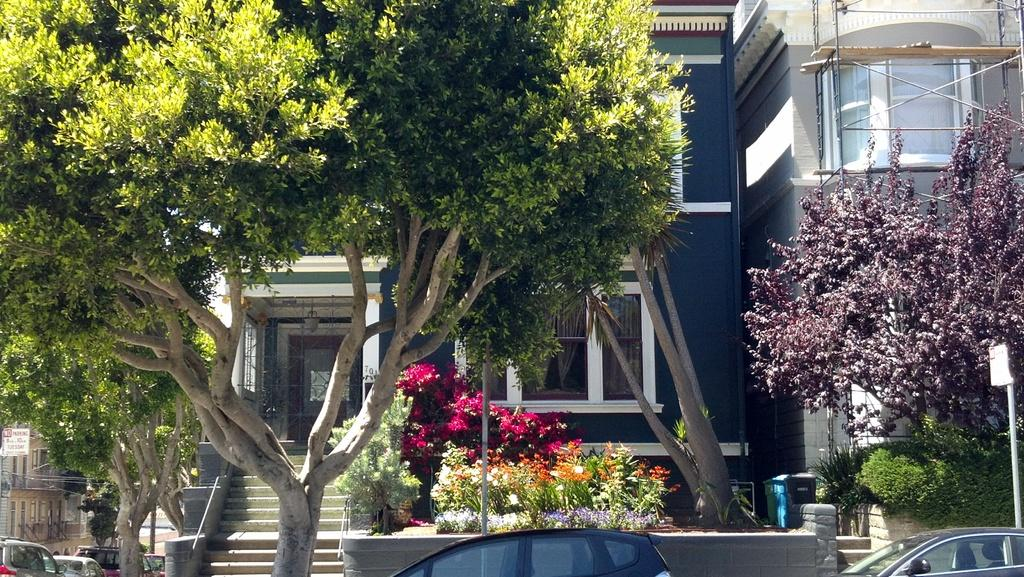What type of structures can be seen in the image? There are buildings in the image. What else is present in the image besides buildings? There are vehicles, trees, plants, poles, stairs, a trash can, and boards in the image. Can you describe any additional features in the image? There are wires in the image. What type of education can be seen on the receipt in the image? There is no receipt or education present in the image. What color is the color of the color in the image? The question is unclear and seems to be referring to the color itself, which is not present in the image. 